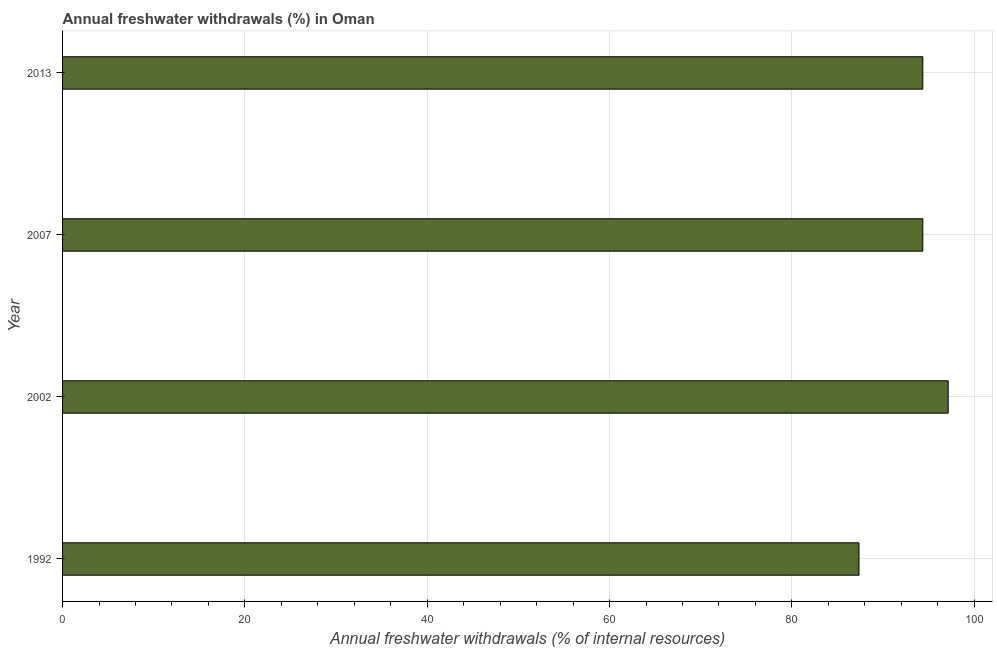What is the title of the graph?
Give a very brief answer. Annual freshwater withdrawals (%) in Oman. What is the label or title of the X-axis?
Keep it short and to the point. Annual freshwater withdrawals (% of internal resources). What is the annual freshwater withdrawals in 2013?
Your answer should be compact. 94.36. Across all years, what is the maximum annual freshwater withdrawals?
Make the answer very short. 97.14. Across all years, what is the minimum annual freshwater withdrawals?
Offer a terse response. 87.36. In which year was the annual freshwater withdrawals maximum?
Offer a very short reply. 2002. What is the sum of the annual freshwater withdrawals?
Provide a short and direct response. 373.21. What is the difference between the annual freshwater withdrawals in 1992 and 2007?
Your answer should be compact. -7. What is the average annual freshwater withdrawals per year?
Offer a terse response. 93.3. What is the median annual freshwater withdrawals?
Your response must be concise. 94.36. Do a majority of the years between 1992 and 2007 (inclusive) have annual freshwater withdrawals greater than 20 %?
Provide a short and direct response. Yes. What is the ratio of the annual freshwater withdrawals in 1992 to that in 2013?
Provide a succinct answer. 0.93. Is the annual freshwater withdrawals in 2007 less than that in 2013?
Give a very brief answer. No. What is the difference between the highest and the second highest annual freshwater withdrawals?
Ensure brevity in your answer.  2.79. What is the difference between the highest and the lowest annual freshwater withdrawals?
Ensure brevity in your answer.  9.79. What is the difference between two consecutive major ticks on the X-axis?
Provide a succinct answer. 20. What is the Annual freshwater withdrawals (% of internal resources) of 1992?
Offer a very short reply. 87.36. What is the Annual freshwater withdrawals (% of internal resources) of 2002?
Provide a short and direct response. 97.14. What is the Annual freshwater withdrawals (% of internal resources) of 2007?
Your answer should be very brief. 94.36. What is the Annual freshwater withdrawals (% of internal resources) of 2013?
Provide a short and direct response. 94.36. What is the difference between the Annual freshwater withdrawals (% of internal resources) in 1992 and 2002?
Keep it short and to the point. -9.79. What is the difference between the Annual freshwater withdrawals (% of internal resources) in 1992 and 2007?
Provide a succinct answer. -7. What is the difference between the Annual freshwater withdrawals (% of internal resources) in 1992 and 2013?
Ensure brevity in your answer.  -7. What is the difference between the Annual freshwater withdrawals (% of internal resources) in 2002 and 2007?
Your answer should be very brief. 2.79. What is the difference between the Annual freshwater withdrawals (% of internal resources) in 2002 and 2013?
Ensure brevity in your answer.  2.79. What is the ratio of the Annual freshwater withdrawals (% of internal resources) in 1992 to that in 2002?
Keep it short and to the point. 0.9. What is the ratio of the Annual freshwater withdrawals (% of internal resources) in 1992 to that in 2007?
Keep it short and to the point. 0.93. What is the ratio of the Annual freshwater withdrawals (% of internal resources) in 1992 to that in 2013?
Your response must be concise. 0.93. What is the ratio of the Annual freshwater withdrawals (% of internal resources) in 2002 to that in 2007?
Provide a succinct answer. 1.03. What is the ratio of the Annual freshwater withdrawals (% of internal resources) in 2002 to that in 2013?
Keep it short and to the point. 1.03. 